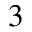<formula> <loc_0><loc_0><loc_500><loc_500>^ { 3 }</formula> 